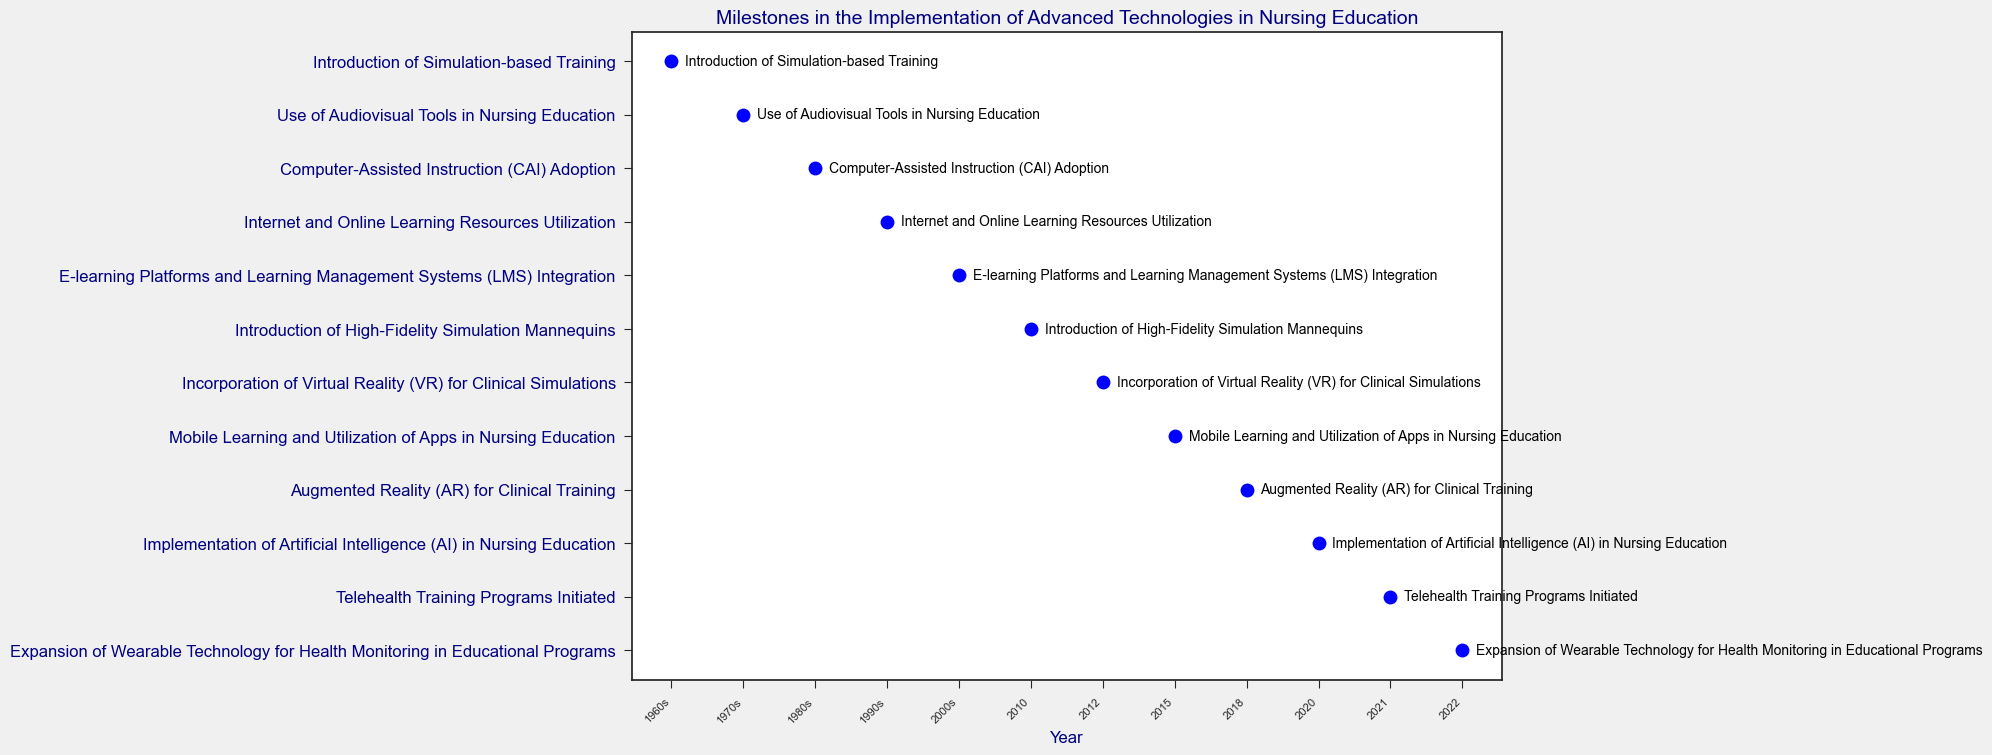Which was the first technology milestone introduced in nursing education? The first milestone listed in the event plot is "Introduction of Simulation-based Training" in the 1960s.
Answer: Introduction of Simulation-based Training Between 2010 and 2015, what advanced technologies were implemented in nursing education? There are two milestones listed between 2010 and 2015: "Introduction of High-Fidelity Simulation Mannequins" in 2010 and "Mobile Learning and Utilization of Apps in Nursing Education" in 2015.
Answer: Introduction of High-Fidelity Simulation Mannequins, Mobile Learning and Utilization of Apps in Nursing Education What milestone was implemented most recently, according to the figure? The most recent milestone on the plot is "Expansion of Wearable Technology for Health Monitoring in Educational Programs" in 2022.
Answer: Expansion of Wearable Technology for Health Monitoring in Educational Programs How many years after the introduction of Computer-Assisted Instruction (CAI) was the use of the Internet and Online Learning Resources implemented in nursing education? The Computer-Assisted Instruction (CAI) was adopted in the 1980s, and the Internet and Online Learning Resources were utilized in the 1990s, indicating a difference of one decade (10 years).
Answer: 10 years Which technology milestone occurred between the adoption of Computer-Assisted Instruction (CAI) and Internet-based learning resources? According to the plot, there were no milestones listed between the 1980s ("Computer-Assisted Instruction (CAI) Adoption") and the 1990s ("Internet and Online Learning Resources Utilization").
Answer: None What is the average year of implementation for the milestones from 2010 to 2022? The listed milestones from 2010 to 2022 are in the years 2010, 2012, 2015, 2018, 2020, 2021, 2022. Adding these years gives \(2010 + 2012 + 2015 + 2018 + 2020 + 2021 + 2022 = 14118\). Dividing by the count of 7 milestones gives \(14118/7 = 2016\).
Answer: 2016 Which milestone was implemented earlier: the Use of Audiovisual Tools or the Computer-Assisted Instruction (CAI)? On the plot, "Use of Audiovisual Tools in Nursing Education" is shown in the 1970s, and "Computer-Assisted Instruction (CAI) Adoption" is in the 1980s. Therefore, the Use of Audiovisual Tools came earlier.
Answer: Use of Audiovisual Tools in Nursing Education Is Virtual Reality (VR) used in nursing education before Augmented Reality (AR)? Referring to the plot, "Incorporation of Virtual Reality (VR) for Clinical Simulations" occurred in 2012, while "Augmented Reality (AR) for Clinical Training" occurred in 2018, indicating VR was used before AR.
Answer: Yes What was the milestone introduced in 2000s, and how did it impact nursing education? The event in the 2000s is "E-learning Platforms and Learning Management Systems (LMS) Integration". This milestone signifies the incorporation of digital platforms to manage and deliver educational content efficiently in nursing programs.
Answer: E-learning Platforms and Learning Management Systems (LMS) Integration 